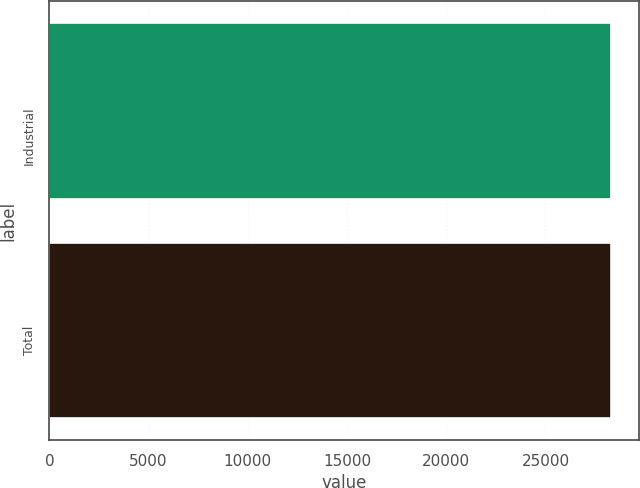<chart> <loc_0><loc_0><loc_500><loc_500><bar_chart><fcel>Industrial<fcel>Total<nl><fcel>28277<fcel>28277.1<nl></chart> 